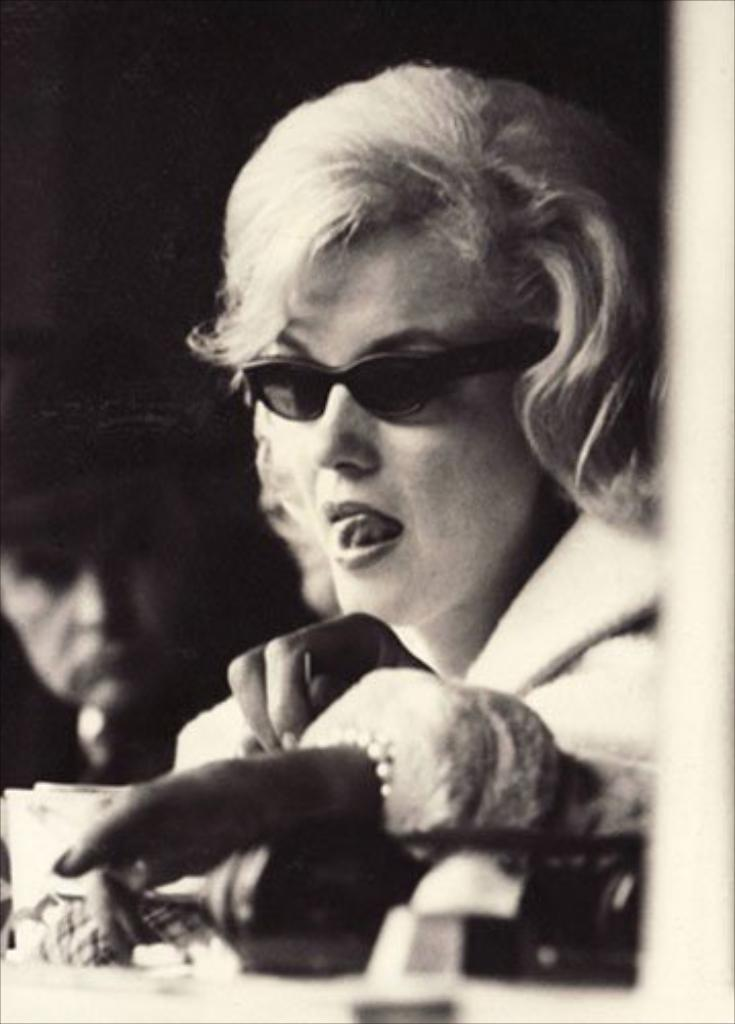What type of photograph is in the image? The image contains a black and white photograph. What is the subject of the photograph? The photograph depicts a woman sitting near a desk. What is the woman wearing in the photograph? The woman is wearing black color goggles. Can you describe the other person visible in the photograph? There is another person's face visible in the photograph. What type of news can be heard in the background of the image? There is no audio or background noise present in the image, so it is not possible to determine what news might be heard. 